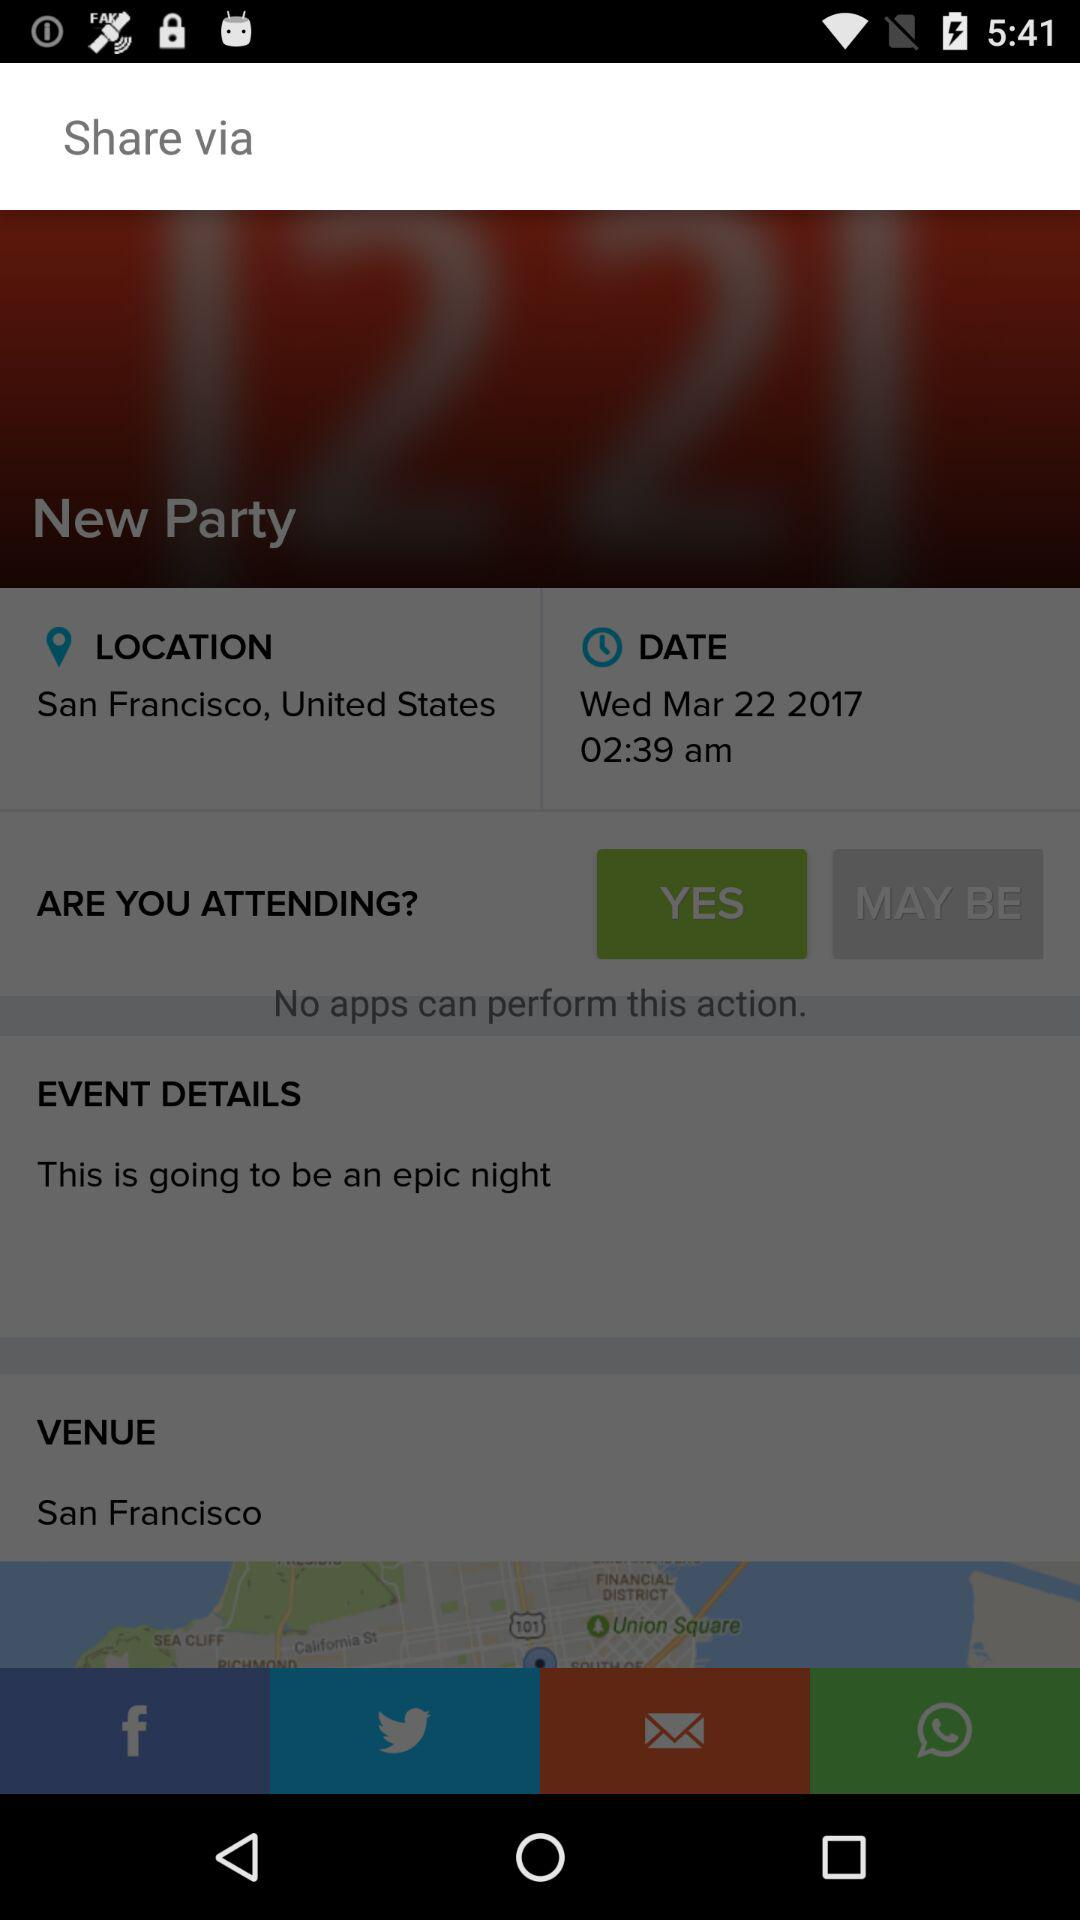What is the date and time? The date is Wednesday, March 22, 2017 and the time is 02:39 a.m. 